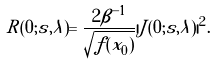Convert formula to latex. <formula><loc_0><loc_0><loc_500><loc_500>R ( 0 ; { s } , \lambda ) = \frac { 2 \beta ^ { - 1 } } { \sqrt { f ( { x } _ { 0 } ) } } | \tilde { J } ( 0 ; { s } , \lambda ) | ^ { 2 } .</formula> 